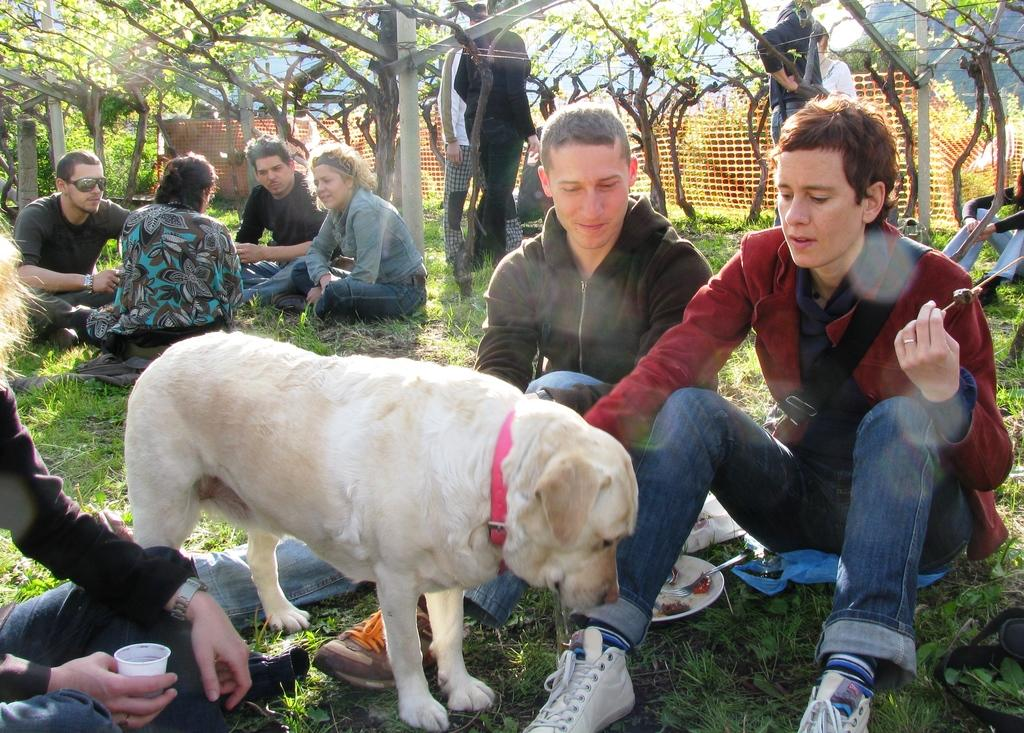How many people are in the image? There are people in the image, but the exact number is not specified. What are the people doing in the image? Some people are standing, while others are sitting on the ground. What other living creature is present in the image? There is a dog in the image. What can be seen in the background of the image? There are trees in the background of the image. Can you see any fish swimming in the image? There are no fish visible in the image. What type of squirrel can be seen climbing the trees in the background? There are no squirrels present in the image; only people, a dog, and trees can be seen. 